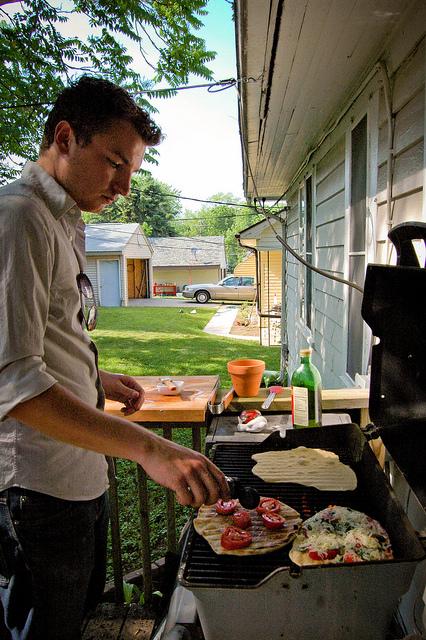Is the man a professional pizza chef?
Quick response, please. No. Is this a family barbecue?
Keep it brief. Yes. Did the man just begin cooking, or is he mid-way through the process?
Be succinct. Midway. Is the man cleaning?
Answer briefly. No. What color is the man's shirt?
Write a very short answer. Gray. What is the man about to cook?
Answer briefly. Pizza. What are the pizza being made on?
Keep it brief. Grill. Are there more than one species of animal in this photo?
Keep it brief. No. 